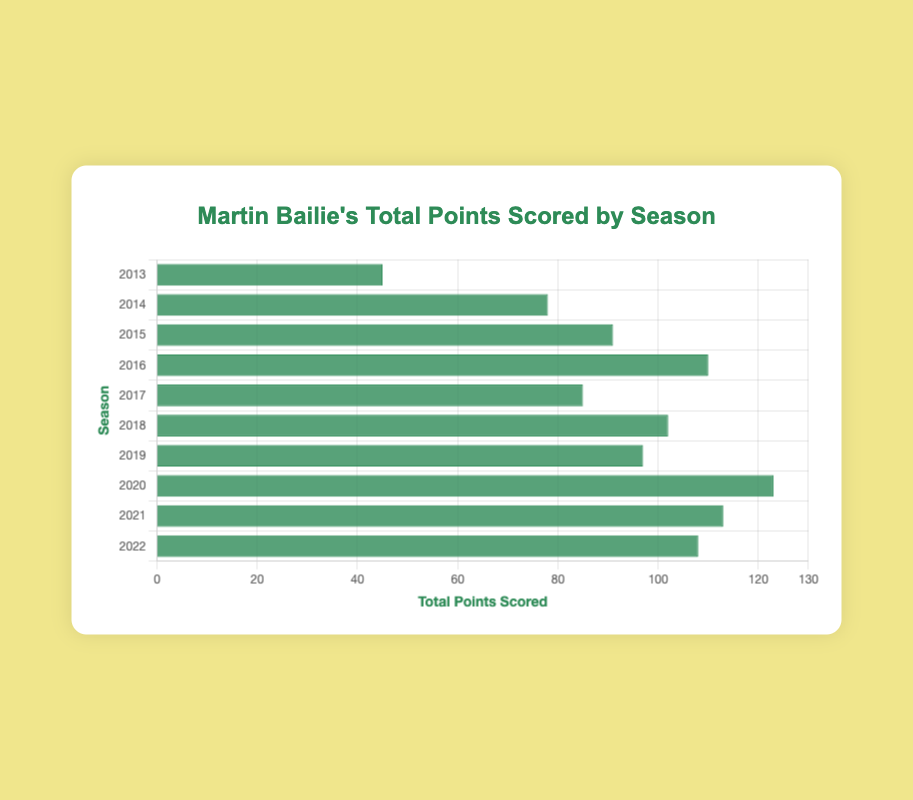Which season had the highest total points scored? Look at the bar corresponding to each season and identify the one with the longest length. The highest bar represents the 2020 season with 123 points.
Answer: 2020 Which season had the lowest total points scored? Compare the lengths of all bars and find the shortest one. The shortest bar belongs to the 2013 season with 45 points.
Answer: 2013 What is the difference in total points scored between the 2020 and 2013 seasons? Find the total points for the 2020 season (123) and 2013 season (45), and subtract the latter from the former: 123 - 45 = 78.
Answer: 78 Which seasons fall within the range of 90 to 110 points scored? Locate the bars whose lengths fall within this range. The seasons are 2015 (91 points), 2016 (110 points), 2018 (102 points), 2019 (97 points), and 2022 (108 points).
Answer: 2015, 2016, 2018, 2019, 2022 On average, how many points did Martin Bailie score per season from 2013 to 2022? Add all the points scored over the seasons: 45 + 78 + 91 + 110 + 85 + 102 + 97 + 123 + 113 + 108 = 952. Then divide by the number of seasons (10). The average is 952 / 10 = 95.2.
Answer: 95.2 Which seasons had total points greater than 100? Identify the bars whose lengths exceed the 100 mark. These are 2016 (110 points), 2018 (102 points), 2020 (123 points), 2021 (113 points), and 2022 (108 points).
Answer: 2016, 2018, 2020, 2021, 2022 How many seasons had total points scored between 80 and 120? Count the bars whose lengths fall within this range. These are 2014 (78 points), 2015 (91 points), 2016 (110 points), 2017 (85 points), 2018 (102 points), 2019 (97 points), 2021 (113 points), and 2022 (108 points). There are 8 such seasons.
Answer: 8 Compare the total points scored in 2017 and 2018, and state which is higher and by how much. The total points in 2017 is 85, while in 2018 it is 102. Subtract the smaller from the larger: 102 - 85 = 17. 2018 scored 17 points more than 2017.
Answer: 2018 by 17 points If we sum up the points scored in 2016 and 2017, what total do we get? The points in 2016 are 110 and in 2017 are 85. Add them together: 110 + 85 = 195.
Answer: 195 Which season had slightly fewer points than 2020 but still over 100? The 2020 season scored 123 points. The seasons with points over 100 are 2016, 2018, 2021, and 2022. The closest one slightly less than 123 points is 2021 with 113 points.
Answer: 2021 